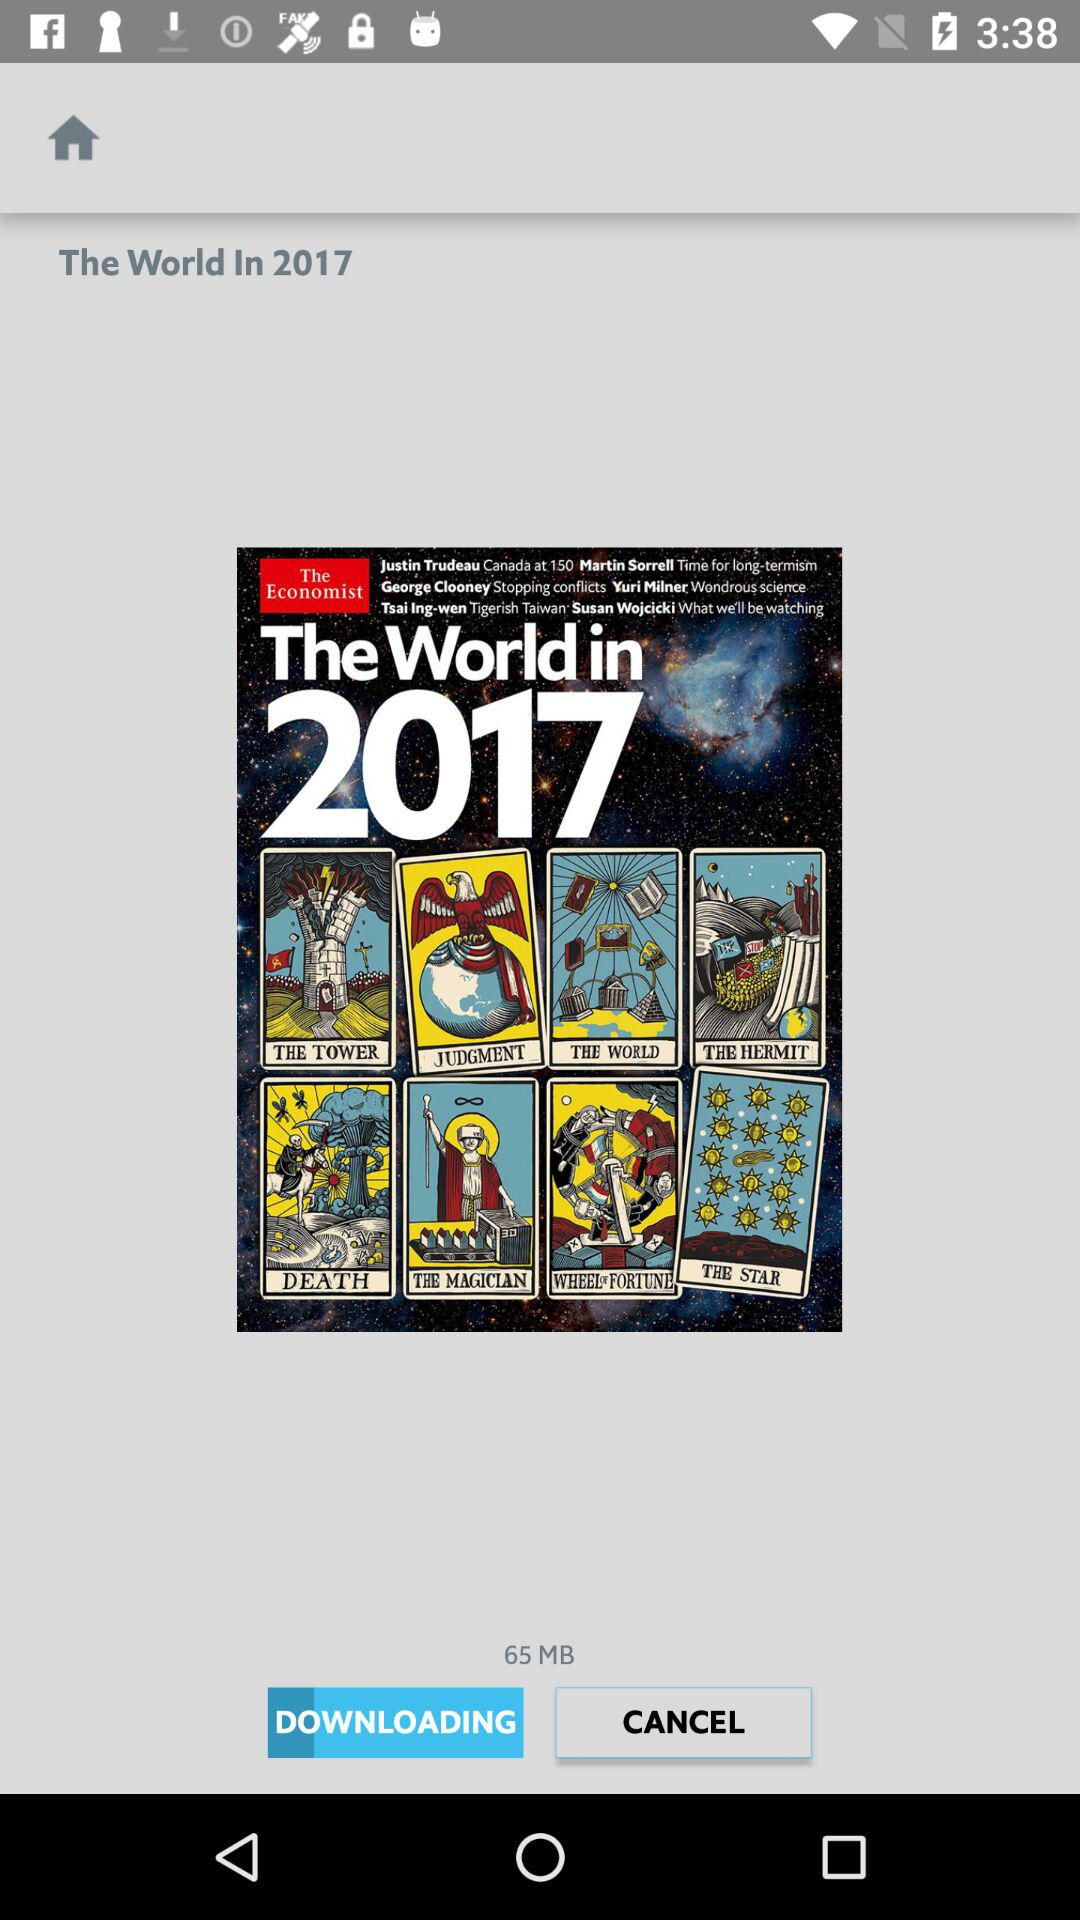What is the size of the download?
Answer the question using a single word or phrase. 65 MB 